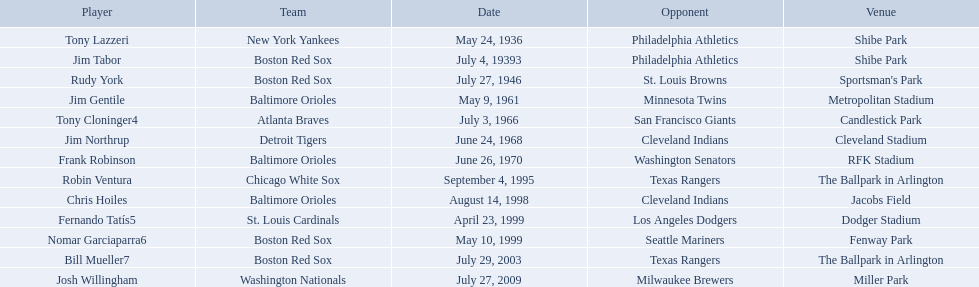What were the dates of each game? May 24, 1936, July 4, 19393, July 27, 1946, May 9, 1961, July 3, 1966, June 24, 1968, June 26, 1970, September 4, 1995, August 14, 1998, April 23, 1999, May 10, 1999, July 29, 2003, July 27, 2009. Who were all of the teams? New York Yankees, Boston Red Sox, Boston Red Sox, Baltimore Orioles, Atlanta Braves, Detroit Tigers, Baltimore Orioles, Chicago White Sox, Baltimore Orioles, St. Louis Cardinals, Boston Red Sox, Boston Red Sox, Washington Nationals. What about their opponents? Philadelphia Athletics, Philadelphia Athletics, St. Louis Browns, Minnesota Twins, San Francisco Giants, Cleveland Indians, Washington Senators, Texas Rangers, Cleveland Indians, Los Angeles Dodgers, Seattle Mariners, Texas Rangers, Milwaukee Brewers. And on which date did the detroit tigers play against the cleveland indians? June 24, 1968. Who are the opponents of the boston red sox during baseball home run records? Philadelphia Athletics, St. Louis Browns, Seattle Mariners, Texas Rangers. Of those which was the opponent on july 27, 1946? St. Louis Browns. Who were all the teams? New York Yankees, Boston Red Sox, Boston Red Sox, Baltimore Orioles, Atlanta Braves, Detroit Tigers, Baltimore Orioles, Chicago White Sox, Baltimore Orioles, St. Louis Cardinals, Boston Red Sox, Boston Red Sox, Washington Nationals. What about opponents? Philadelphia Athletics, Philadelphia Athletics, St. Louis Browns, Minnesota Twins, San Francisco Giants, Cleveland Indians, Washington Senators, Texas Rangers, Cleveland Indians, Los Angeles Dodgers, Seattle Mariners, Texas Rangers, Milwaukee Brewers. And when did they play? May 24, 1936, July 4, 19393, July 27, 1946, May 9, 1961, July 3, 1966, June 24, 1968, June 26, 1970, September 4, 1995, August 14, 1998, April 23, 1999, May 10, 1999, July 29, 2003, July 27, 2009. Which team played the red sox on july 27, 1946	? St. Louis Browns. Who were all of the players? Tony Lazzeri, Jim Tabor, Rudy York, Jim Gentile, Tony Cloninger4, Jim Northrup, Frank Robinson, Robin Ventura, Chris Hoiles, Fernando Tatís5, Nomar Garciaparra6, Bill Mueller7, Josh Willingham. What year was there a player for the yankees? May 24, 1936. What was the name of that 1936 yankees player? Tony Lazzeri. At which location did detroit compete against cleveland? Cleveland Stadium. Who was the participant? Jim Northrup. On which day did the game occur? June 24, 1968. Can you parse all the data within this table? {'header': ['Player', 'Team', 'Date', 'Opponent', 'Venue'], 'rows': [['Tony Lazzeri', 'New York Yankees', 'May 24, 1936', 'Philadelphia Athletics', 'Shibe Park'], ['Jim Tabor', 'Boston Red Sox', 'July 4, 19393', 'Philadelphia Athletics', 'Shibe Park'], ['Rudy York', 'Boston Red Sox', 'July 27, 1946', 'St. Louis Browns', "Sportsman's Park"], ['Jim Gentile', 'Baltimore Orioles', 'May 9, 1961', 'Minnesota Twins', 'Metropolitan Stadium'], ['Tony Cloninger4', 'Atlanta Braves', 'July 3, 1966', 'San Francisco Giants', 'Candlestick Park'], ['Jim Northrup', 'Detroit Tigers', 'June 24, 1968', 'Cleveland Indians', 'Cleveland Stadium'], ['Frank Robinson', 'Baltimore Orioles', 'June 26, 1970', 'Washington Senators', 'RFK Stadium'], ['Robin Ventura', 'Chicago White Sox', 'September 4, 1995', 'Texas Rangers', 'The Ballpark in Arlington'], ['Chris Hoiles', 'Baltimore Orioles', 'August 14, 1998', 'Cleveland Indians', 'Jacobs Field'], ['Fernando Tatís5', 'St. Louis Cardinals', 'April 23, 1999', 'Los Angeles Dodgers', 'Dodger Stadium'], ['Nomar Garciaparra6', 'Boston Red Sox', 'May 10, 1999', 'Seattle Mariners', 'Fenway Park'], ['Bill Mueller7', 'Boston Red Sox', 'July 29, 2003', 'Texas Rangers', 'The Ballpark in Arlington'], ['Josh Willingham', 'Washington Nationals', 'July 27, 2009', 'Milwaukee Brewers', 'Miller Park']]} Which teams participated between the years 1960 and 1970? Baltimore Orioles, Atlanta Braves, Detroit Tigers, Baltimore Orioles. Among these teams that participated, which ones competed against the cleveland indians? Detroit Tigers. On what date did these two teams compete? June 24, 1968. Between the years 1960 and 1970, which teams were active? Baltimore Orioles, Atlanta Braves, Detroit Tigers, Baltimore Orioles. Of these active teams, which ones played against the cleveland indians? Detroit Tigers. Could you parse the entire table? {'header': ['Player', 'Team', 'Date', 'Opponent', 'Venue'], 'rows': [['Tony Lazzeri', 'New York Yankees', 'May 24, 1936', 'Philadelphia Athletics', 'Shibe Park'], ['Jim Tabor', 'Boston Red Sox', 'July 4, 19393', 'Philadelphia Athletics', 'Shibe Park'], ['Rudy York', 'Boston Red Sox', 'July 27, 1946', 'St. Louis Browns', "Sportsman's Park"], ['Jim Gentile', 'Baltimore Orioles', 'May 9, 1961', 'Minnesota Twins', 'Metropolitan Stadium'], ['Tony Cloninger4', 'Atlanta Braves', 'July 3, 1966', 'San Francisco Giants', 'Candlestick Park'], ['Jim Northrup', 'Detroit Tigers', 'June 24, 1968', 'Cleveland Indians', 'Cleveland Stadium'], ['Frank Robinson', 'Baltimore Orioles', 'June 26, 1970', 'Washington Senators', 'RFK Stadium'], ['Robin Ventura', 'Chicago White Sox', 'September 4, 1995', 'Texas Rangers', 'The Ballpark in Arlington'], ['Chris Hoiles', 'Baltimore Orioles', 'August 14, 1998', 'Cleveland Indians', 'Jacobs Field'], ['Fernando Tatís5', 'St. Louis Cardinals', 'April 23, 1999', 'Los Angeles Dodgers', 'Dodger Stadium'], ['Nomar Garciaparra6', 'Boston Red Sox', 'May 10, 1999', 'Seattle Mariners', 'Fenway Park'], ['Bill Mueller7', 'Boston Red Sox', 'July 29, 2003', 'Texas Rangers', 'The Ballpark in Arlington'], ['Josh Willingham', 'Washington Nationals', 'July 27, 2009', 'Milwaukee Brewers', 'Miller Park']]} On what specific day did these two teams encounter each other? June 24, 1968. Who are all the competitors? Philadelphia Athletics, Philadelphia Athletics, St. Louis Browns, Minnesota Twins, San Francisco Giants, Cleveland Indians, Washington Senators, Texas Rangers, Cleveland Indians, Los Angeles Dodgers, Seattle Mariners, Texas Rangers, Milwaukee Brewers. What teams participated on july 27, 1946? Boston Red Sox, July 27, 1946, St. Louis Browns. Who was the opposition in this game? St. Louis Browns. What are the timeframes? May 24, 1936, July 4, 19393, July 27, 1946, May 9, 1961, July 3, 1966, June 24, 1968, June 26, 1970, September 4, 1995, August 14, 1998, April 23, 1999, May 10, 1999, July 29, 2003, July 27, 2009. Which timeframe is in 1936? May 24, 1936. Which participant is mentioned for this timeframe? Tony Lazzeri. At which location did detroit compete against cleveland? Cleveland Stadium. Who was the participant? Jim Northrup. On what day did the match occur? June 24, 1968. Where did the detroit vs. cleveland game take place? Cleveland Stadium. Which athlete was involved? Jim Northrup. When was the event held? June 24, 1968. Write the full table. {'header': ['Player', 'Team', 'Date', 'Opponent', 'Venue'], 'rows': [['Tony Lazzeri', 'New York Yankees', 'May 24, 1936', 'Philadelphia Athletics', 'Shibe Park'], ['Jim Tabor', 'Boston Red Sox', 'July 4, 19393', 'Philadelphia Athletics', 'Shibe Park'], ['Rudy York', 'Boston Red Sox', 'July 27, 1946', 'St. Louis Browns', "Sportsman's Park"], ['Jim Gentile', 'Baltimore Orioles', 'May 9, 1961', 'Minnesota Twins', 'Metropolitan Stadium'], ['Tony Cloninger4', 'Atlanta Braves', 'July 3, 1966', 'San Francisco Giants', 'Candlestick Park'], ['Jim Northrup', 'Detroit Tigers', 'June 24, 1968', 'Cleveland Indians', 'Cleveland Stadium'], ['Frank Robinson', 'Baltimore Orioles', 'June 26, 1970', 'Washington Senators', 'RFK Stadium'], ['Robin Ventura', 'Chicago White Sox', 'September 4, 1995', 'Texas Rangers', 'The Ballpark in Arlington'], ['Chris Hoiles', 'Baltimore Orioles', 'August 14, 1998', 'Cleveland Indians', 'Jacobs Field'], ['Fernando Tatís5', 'St. Louis Cardinals', 'April 23, 1999', 'Los Angeles Dodgers', 'Dodger Stadium'], ['Nomar Garciaparra6', 'Boston Red Sox', 'May 10, 1999', 'Seattle Mariners', 'Fenway Park'], ['Bill Mueller7', 'Boston Red Sox', 'July 29, 2003', 'Texas Rangers', 'The Ballpark in Arlington'], ['Josh Willingham', 'Washington Nationals', 'July 27, 2009', 'Milwaukee Brewers', 'Miller Park']]} In which facility did the detroit team face cleveland? Cleveland Stadium. Who was the sportsman? Jim Northrup. What was the schedule of their game? June 24, 1968. What were the names of all the teams? New York Yankees, Boston Red Sox, Boston Red Sox, Baltimore Orioles, Atlanta Braves, Detroit Tigers, Baltimore Orioles, Chicago White Sox, Baltimore Orioles, St. Louis Cardinals, Boston Red Sox, Boston Red Sox, Washington Nationals. Who were their rivals? Philadelphia Athletics, Philadelphia Athletics, St. Louis Browns, Minnesota Twins, San Francisco Giants, Cleveland Indians, Washington Senators, Texas Rangers, Cleveland Indians, Los Angeles Dodgers, Seattle Mariners, Texas Rangers, Milwaukee Brewers. When did the games take place? May 24, 1936, July 4, 19393, July 27, 1946, May 9, 1961, July 3, 1966, June 24, 1968, June 26, 1970, September 4, 1995, August 14, 1998, April 23, 1999, May 10, 1999, July 29, 2003, July 27, 2009. I'm looking to parse the entire table for insights. Could you assist me with that? {'header': ['Player', 'Team', 'Date', 'Opponent', 'Venue'], 'rows': [['Tony Lazzeri', 'New York Yankees', 'May 24, 1936', 'Philadelphia Athletics', 'Shibe Park'], ['Jim Tabor', 'Boston Red Sox', 'July 4, 19393', 'Philadelphia Athletics', 'Shibe Park'], ['Rudy York', 'Boston Red Sox', 'July 27, 1946', 'St. Louis Browns', "Sportsman's Park"], ['Jim Gentile', 'Baltimore Orioles', 'May 9, 1961', 'Minnesota Twins', 'Metropolitan Stadium'], ['Tony Cloninger4', 'Atlanta Braves', 'July 3, 1966', 'San Francisco Giants', 'Candlestick Park'], ['Jim Northrup', 'Detroit Tigers', 'June 24, 1968', 'Cleveland Indians', 'Cleveland Stadium'], ['Frank Robinson', 'Baltimore Orioles', 'June 26, 1970', 'Washington Senators', 'RFK Stadium'], ['Robin Ventura', 'Chicago White Sox', 'September 4, 1995', 'Texas Rangers', 'The Ballpark in Arlington'], ['Chris Hoiles', 'Baltimore Orioles', 'August 14, 1998', 'Cleveland Indians', 'Jacobs Field'], ['Fernando Tatís5', 'St. Louis Cardinals', 'April 23, 1999', 'Los Angeles Dodgers', 'Dodger Stadium'], ['Nomar Garciaparra6', 'Boston Red Sox', 'May 10, 1999', 'Seattle Mariners', 'Fenway Park'], ['Bill Mueller7', 'Boston Red Sox', 'July 29, 2003', 'Texas Rangers', 'The Ballpark in Arlington'], ['Josh Willingham', 'Washington Nationals', 'July 27, 2009', 'Milwaukee Brewers', 'Miller Park']]} On july 27, 1946, who played against the red sox? St. Louis Browns. What are the names of each player? Tony Lazzeri, Jim Tabor, Rudy York, Jim Gentile, Tony Cloninger4, Jim Northrup, Frank Robinson, Robin Ventura, Chris Hoiles, Fernando Tatís5, Nomar Garciaparra6, Bill Mueller7, Josh Willingham. Which teams possess home run records? New York Yankees, Boston Red Sox, Baltimore Orioles, Atlanta Braves, Detroit Tigers, Chicago White Sox, St. Louis Cardinals, Washington Nationals. Which individual played on the new york yankees team? Tony Lazzeri. What are the specific dates? May 24, 1936, July 4, 19393, July 27, 1946, May 9, 1961, July 3, 1966, June 24, 1968, June 26, 1970, September 4, 1995, August 14, 1998, April 23, 1999, May 10, 1999, July 29, 2003, July 27, 2009. Which one falls in 1936? May 24, 1936. Which player is mentioned for that particular date? Tony Lazzeri. Can you provide the dates? May 24, 1936, July 4, 19393, July 27, 1946, May 9, 1961, July 3, 1966, June 24, 1968, June 26, 1970, September 4, 1995, August 14, 1998, April 23, 1999, May 10, 1999, July 29, 2003, July 27, 2009. Which of these dates is from 1936? May 24, 1936. What is the name of the player associated with this date? Tony Lazzeri. Could you list the dates? May 24, 1936, July 4, 19393, July 27, 1946, May 9, 1961, July 3, 1966, June 24, 1968, June 26, 1970, September 4, 1995, August 14, 1998, April 23, 1999, May 10, 1999, July 29, 2003, July 27, 2009. Which date corresponds to 1936? May 24, 1936. Which player is linked to this date? Tony Lazzeri. 